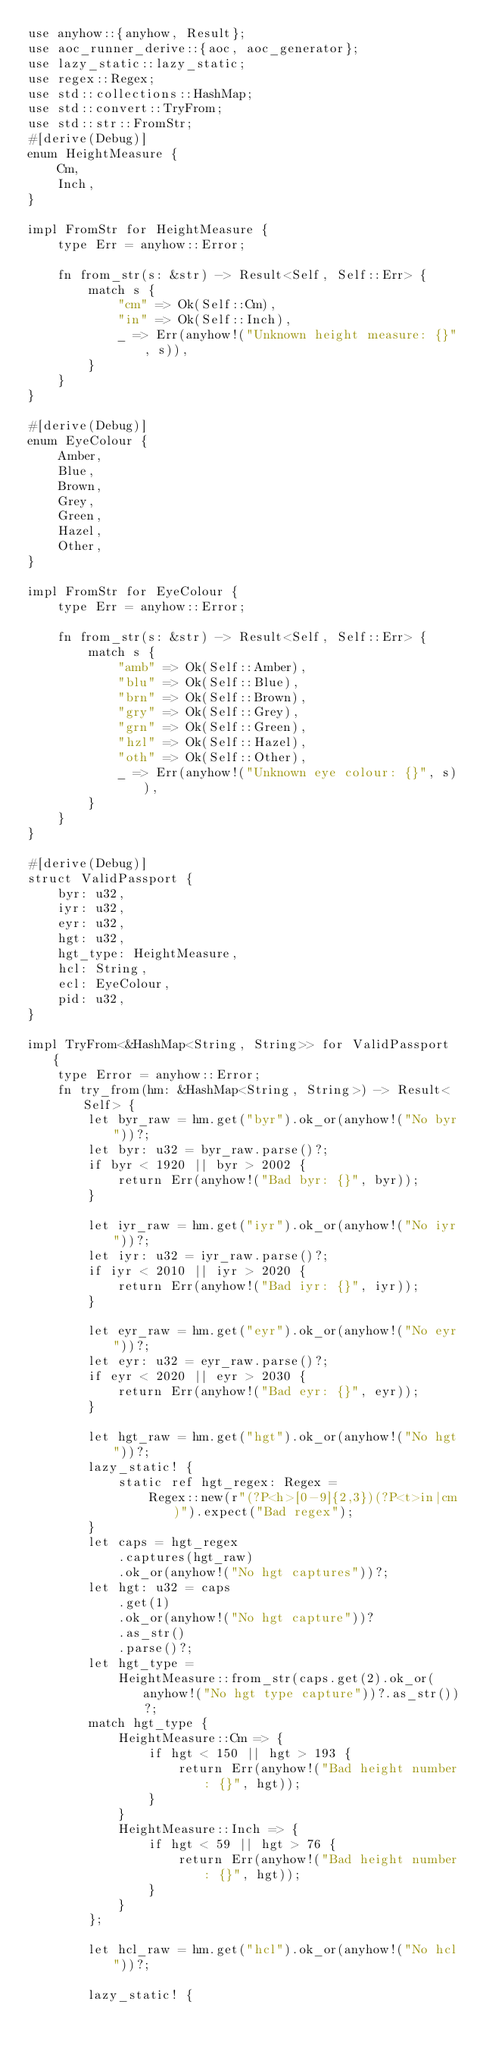<code> <loc_0><loc_0><loc_500><loc_500><_Rust_>use anyhow::{anyhow, Result};
use aoc_runner_derive::{aoc, aoc_generator};
use lazy_static::lazy_static;
use regex::Regex;
use std::collections::HashMap;
use std::convert::TryFrom;
use std::str::FromStr;
#[derive(Debug)]
enum HeightMeasure {
    Cm,
    Inch,
}

impl FromStr for HeightMeasure {
    type Err = anyhow::Error;

    fn from_str(s: &str) -> Result<Self, Self::Err> {
        match s {
            "cm" => Ok(Self::Cm),
            "in" => Ok(Self::Inch),
            _ => Err(anyhow!("Unknown height measure: {}", s)),
        }
    }
}

#[derive(Debug)]
enum EyeColour {
    Amber,
    Blue,
    Brown,
    Grey,
    Green,
    Hazel,
    Other,
}

impl FromStr for EyeColour {
    type Err = anyhow::Error;

    fn from_str(s: &str) -> Result<Self, Self::Err> {
        match s {
            "amb" => Ok(Self::Amber),
            "blu" => Ok(Self::Blue),
            "brn" => Ok(Self::Brown),
            "gry" => Ok(Self::Grey),
            "grn" => Ok(Self::Green),
            "hzl" => Ok(Self::Hazel),
            "oth" => Ok(Self::Other),
            _ => Err(anyhow!("Unknown eye colour: {}", s)),
        }
    }
}

#[derive(Debug)]
struct ValidPassport {
    byr: u32,
    iyr: u32,
    eyr: u32,
    hgt: u32,
    hgt_type: HeightMeasure,
    hcl: String,
    ecl: EyeColour,
    pid: u32,
}

impl TryFrom<&HashMap<String, String>> for ValidPassport {
    type Error = anyhow::Error;
    fn try_from(hm: &HashMap<String, String>) -> Result<Self> {
        let byr_raw = hm.get("byr").ok_or(anyhow!("No byr"))?;
        let byr: u32 = byr_raw.parse()?;
        if byr < 1920 || byr > 2002 {
            return Err(anyhow!("Bad byr: {}", byr));
        }

        let iyr_raw = hm.get("iyr").ok_or(anyhow!("No iyr"))?;
        let iyr: u32 = iyr_raw.parse()?;
        if iyr < 2010 || iyr > 2020 {
            return Err(anyhow!("Bad iyr: {}", iyr));
        }

        let eyr_raw = hm.get("eyr").ok_or(anyhow!("No eyr"))?;
        let eyr: u32 = eyr_raw.parse()?;
        if eyr < 2020 || eyr > 2030 {
            return Err(anyhow!("Bad eyr: {}", eyr));
        }

        let hgt_raw = hm.get("hgt").ok_or(anyhow!("No hgt"))?;
        lazy_static! {
            static ref hgt_regex: Regex =
                Regex::new(r"(?P<h>[0-9]{2,3})(?P<t>in|cm)").expect("Bad regex");
        }
        let caps = hgt_regex
            .captures(hgt_raw)
            .ok_or(anyhow!("No hgt captures"))?;
        let hgt: u32 = caps
            .get(1)
            .ok_or(anyhow!("No hgt capture"))?
            .as_str()
            .parse()?;
        let hgt_type =
            HeightMeasure::from_str(caps.get(2).ok_or(anyhow!("No hgt type capture"))?.as_str())?;
        match hgt_type {
            HeightMeasure::Cm => {
                if hgt < 150 || hgt > 193 {
                    return Err(anyhow!("Bad height number: {}", hgt));
                }
            }
            HeightMeasure::Inch => {
                if hgt < 59 || hgt > 76 {
                    return Err(anyhow!("Bad height number: {}", hgt));
                }
            }
        };

        let hcl_raw = hm.get("hcl").ok_or(anyhow!("No hcl"))?;

        lazy_static! {</code> 